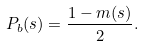Convert formula to latex. <formula><loc_0><loc_0><loc_500><loc_500>P _ { b } ( s ) = \frac { 1 - m ( s ) } 2 .</formula> 